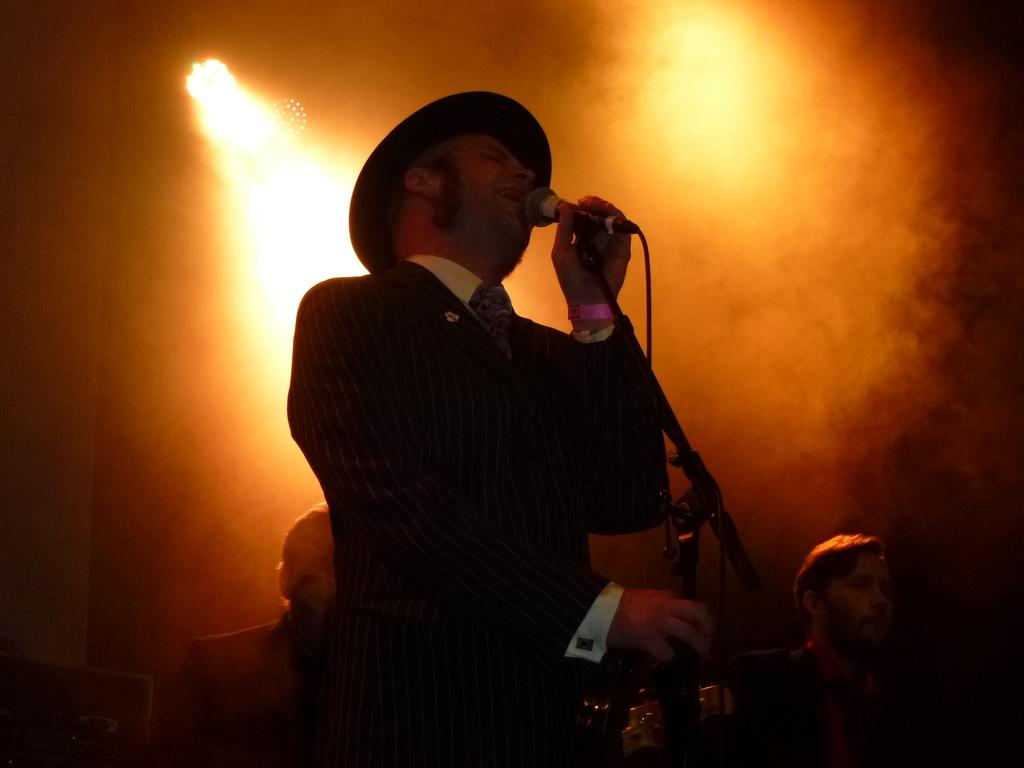What is the man in the image doing? The man is singing. What is the man holding in the image? The man is holding a microphone. Can you describe the man's attire in the image? The man is wearing a hat. How many trains can be seen in the image? There are no trains present in the image. 